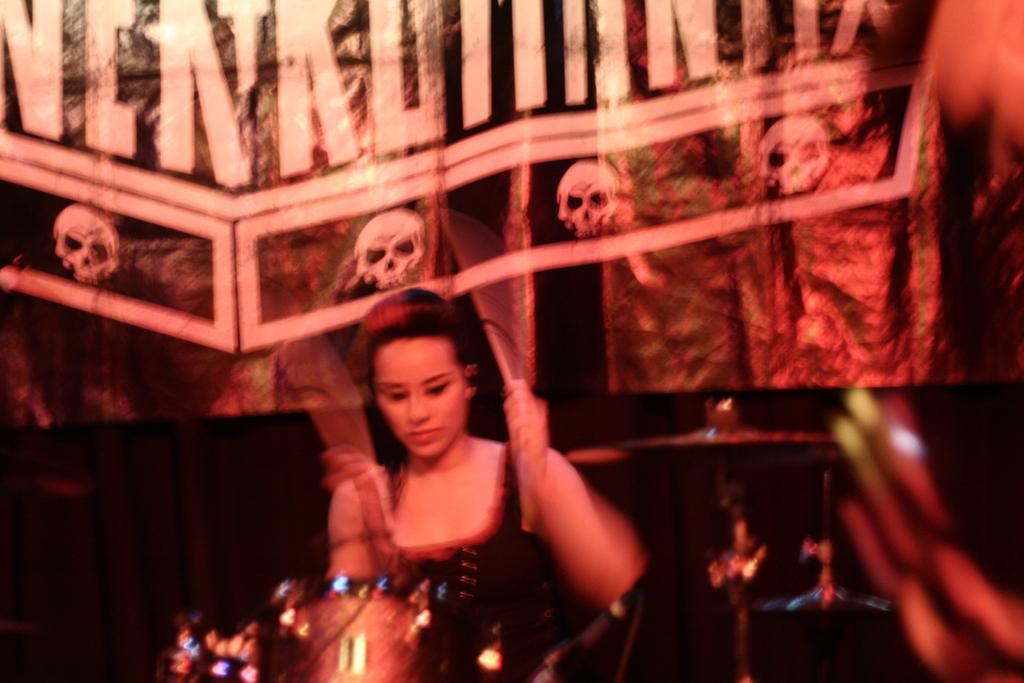Please provide a concise description of this image. In this image we can see a woman playing a musical instrument and in the background we can see the posters. 